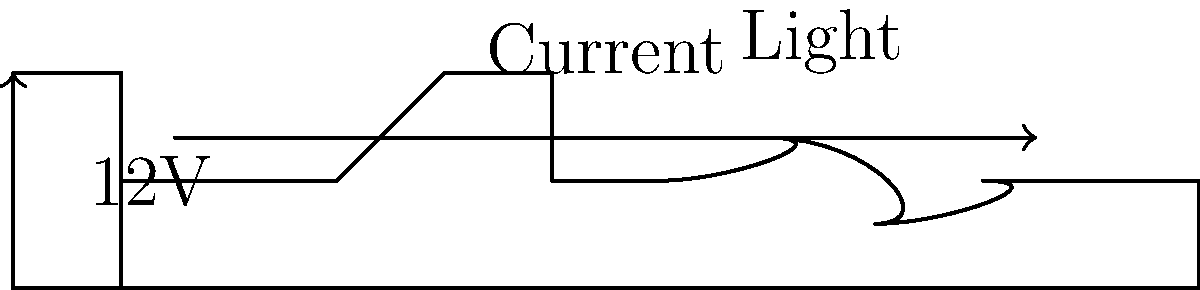In the simple circuit diagram shown above, what will happen to the light when the switch is closed? To understand what happens when the switch is closed, let's analyze the circuit step-by-step:

1. The circuit consists of three main components:
   a) A 12V battery (power source)
   b) A switch (control element)
   c) A light bulb (represented by the resistor symbol)

2. When the switch is open (as shown in the diagram), the circuit is incomplete. This means no current can flow from the battery to the light bulb.

3. When the switch is closed:
   a) It creates a complete path for the current to flow from the positive terminal of the battery, through the switch, through the light bulb, and back to the negative terminal of the battery.
   b) This completed circuit allows electrons to flow, creating an electric current.

4. As current flows through the light bulb (which acts as a resistor):
   a) The electrical energy is converted into light and heat energy due to the resistance in the filament.
   b) This causes the light bulb to illuminate.

5. The arrow in the diagram indicates the conventional current flow, which is opposite to the actual flow of electrons but is the standard way of representing current in electrical diagrams.

Therefore, when the switch is closed, the circuit will be complete, allowing current to flow and causing the light bulb to turn on and emit light.
Answer: The light will turn on. 